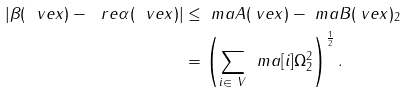Convert formula to latex. <formula><loc_0><loc_0><loc_500><loc_500>| \beta ( \ v e { x } ) - \ r e \alpha ( \ v e { x } ) | & \leq \| \ m a { A } ( \ v e { x } ) - \ m a { B } ( \ v e { x } ) \| _ { 2 } \\ & = \left ( \sum _ { i \in \ V } \, \| \ m a [ i ] { \Omega } \| ^ { 2 } _ { 2 } \right ) ^ { \frac { 1 } { 2 } } .</formula> 